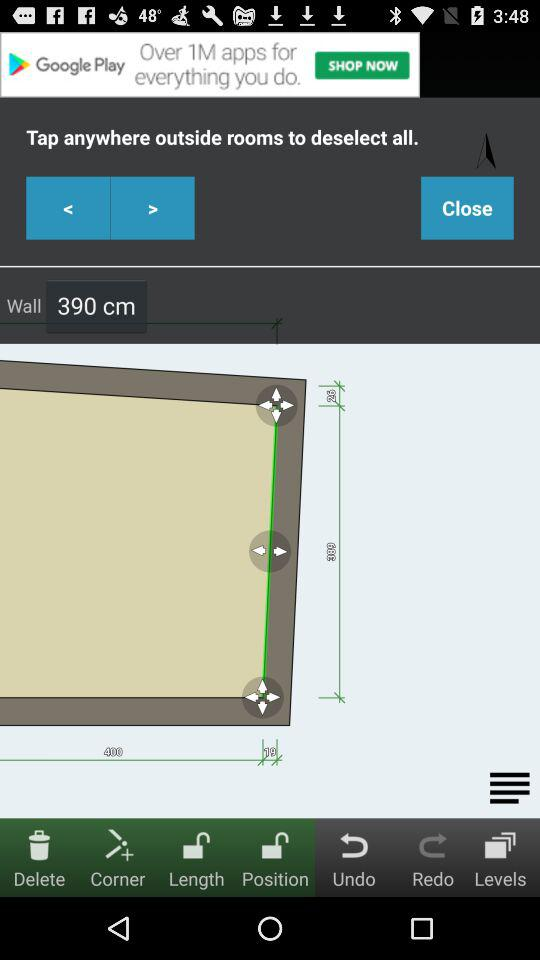Which tabs are unlocked? The unlocked tabs are "Delete", "Corner", "Length" and "Position". 